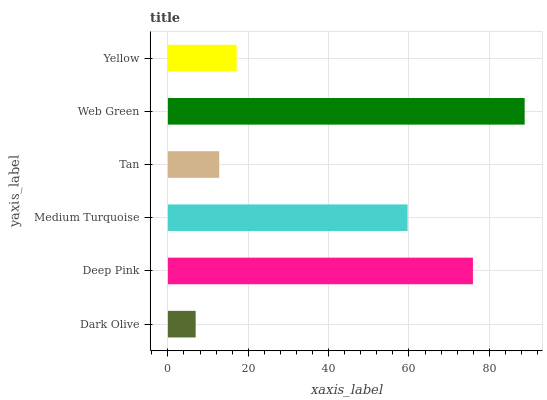Is Dark Olive the minimum?
Answer yes or no. Yes. Is Web Green the maximum?
Answer yes or no. Yes. Is Deep Pink the minimum?
Answer yes or no. No. Is Deep Pink the maximum?
Answer yes or no. No. Is Deep Pink greater than Dark Olive?
Answer yes or no. Yes. Is Dark Olive less than Deep Pink?
Answer yes or no. Yes. Is Dark Olive greater than Deep Pink?
Answer yes or no. No. Is Deep Pink less than Dark Olive?
Answer yes or no. No. Is Medium Turquoise the high median?
Answer yes or no. Yes. Is Yellow the low median?
Answer yes or no. Yes. Is Yellow the high median?
Answer yes or no. No. Is Dark Olive the low median?
Answer yes or no. No. 